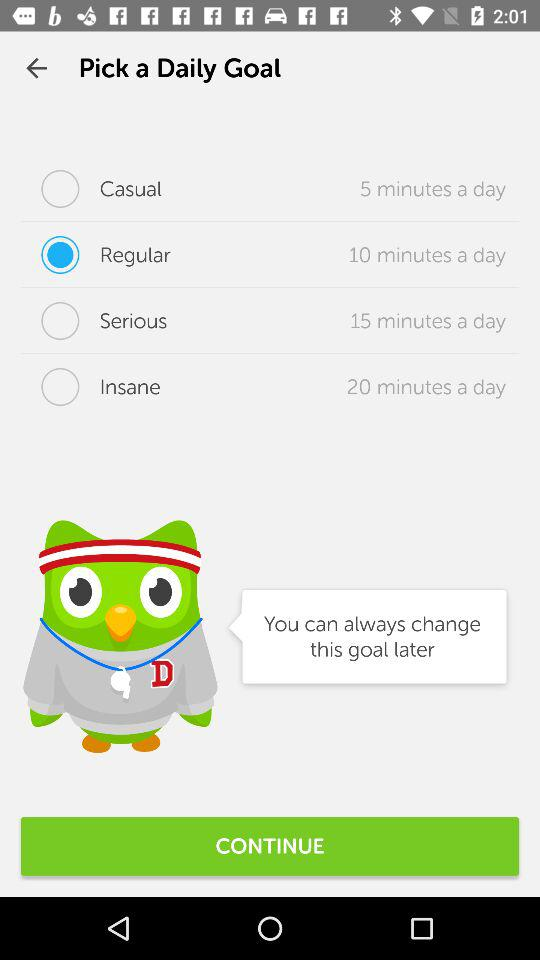What's the duration of the "Regular" daily goal? The duration is 10 minutes a day. 